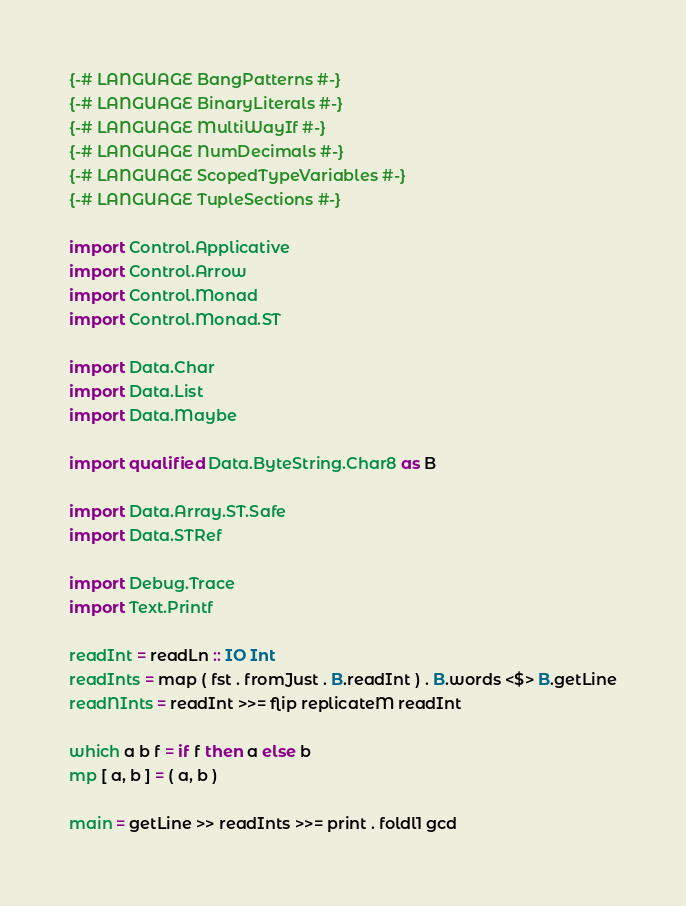<code> <loc_0><loc_0><loc_500><loc_500><_Haskell_>{-# LANGUAGE BangPatterns #-}
{-# LANGUAGE BinaryLiterals #-}
{-# LANGUAGE MultiWayIf #-}
{-# LANGUAGE NumDecimals #-}
{-# LANGUAGE ScopedTypeVariables #-}
{-# LANGUAGE TupleSections #-}

import Control.Applicative
import Control.Arrow
import Control.Monad
import Control.Monad.ST

import Data.Char
import Data.List
import Data.Maybe

import qualified Data.ByteString.Char8 as B

import Data.Array.ST.Safe
import Data.STRef

import Debug.Trace
import Text.Printf

readInt = readLn :: IO Int
readInts = map ( fst . fromJust . B.readInt ) . B.words <$> B.getLine
readNInts = readInt >>= flip replicateM readInt

which a b f = if f then a else b
mp [ a, b ] = ( a, b )

main = getLine >> readInts >>= print . foldl1 gcd </code> 